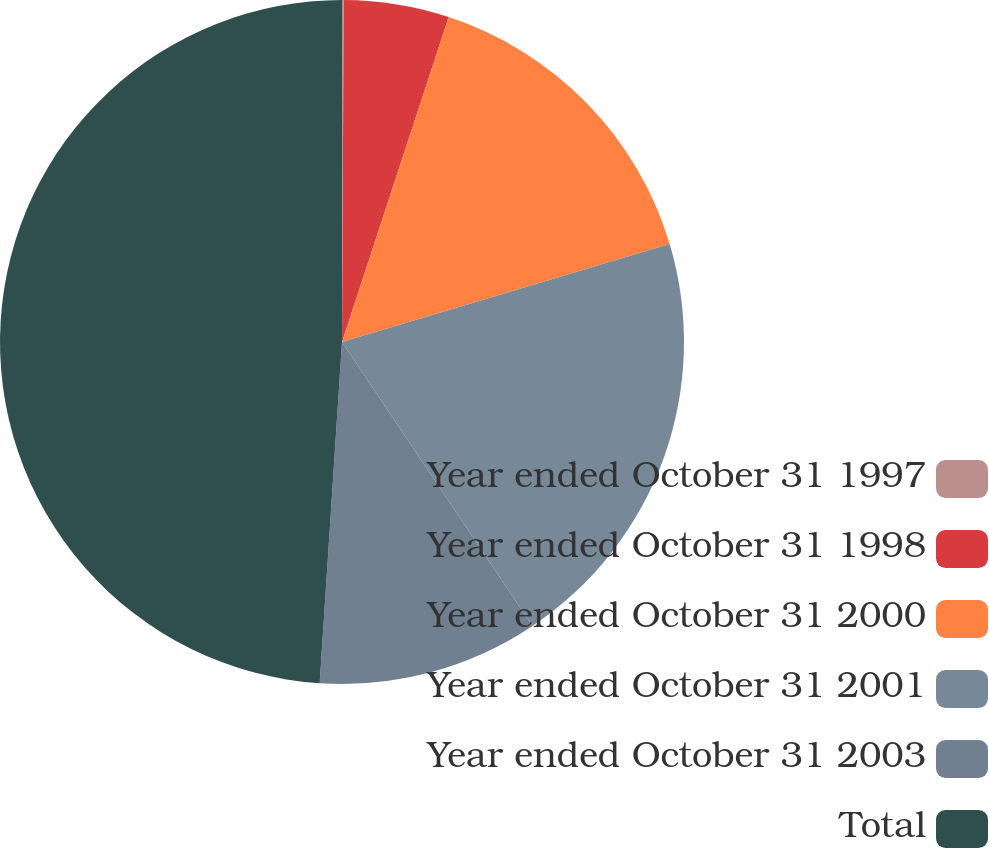Convert chart. <chart><loc_0><loc_0><loc_500><loc_500><pie_chart><fcel>Year ended October 31 1997<fcel>Year ended October 31 1998<fcel>Year ended October 31 2000<fcel>Year ended October 31 2001<fcel>Year ended October 31 2003<fcel>Total<nl><fcel>0.08%<fcel>4.97%<fcel>15.33%<fcel>20.22%<fcel>10.44%<fcel>48.96%<nl></chart> 